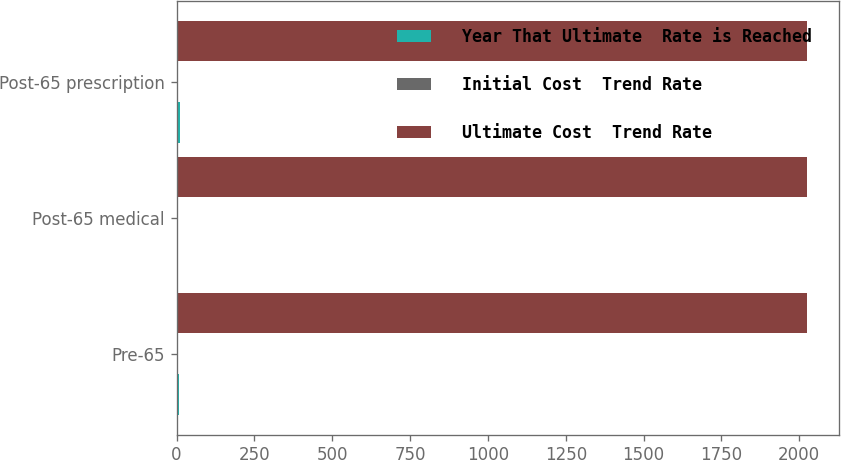<chart> <loc_0><loc_0><loc_500><loc_500><stacked_bar_chart><ecel><fcel>Pre-65<fcel>Post-65 medical<fcel>Post-65 prescription<nl><fcel>Year That Ultimate  Rate is Reached<fcel>6.5<fcel>5<fcel>10<nl><fcel>Initial Cost  Trend Rate<fcel>4.5<fcel>4.5<fcel>4.5<nl><fcel>Ultimate Cost  Trend Rate<fcel>2026<fcel>2026<fcel>2026<nl></chart> 